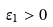<formula> <loc_0><loc_0><loc_500><loc_500>\epsilon _ { 1 } > 0</formula> 